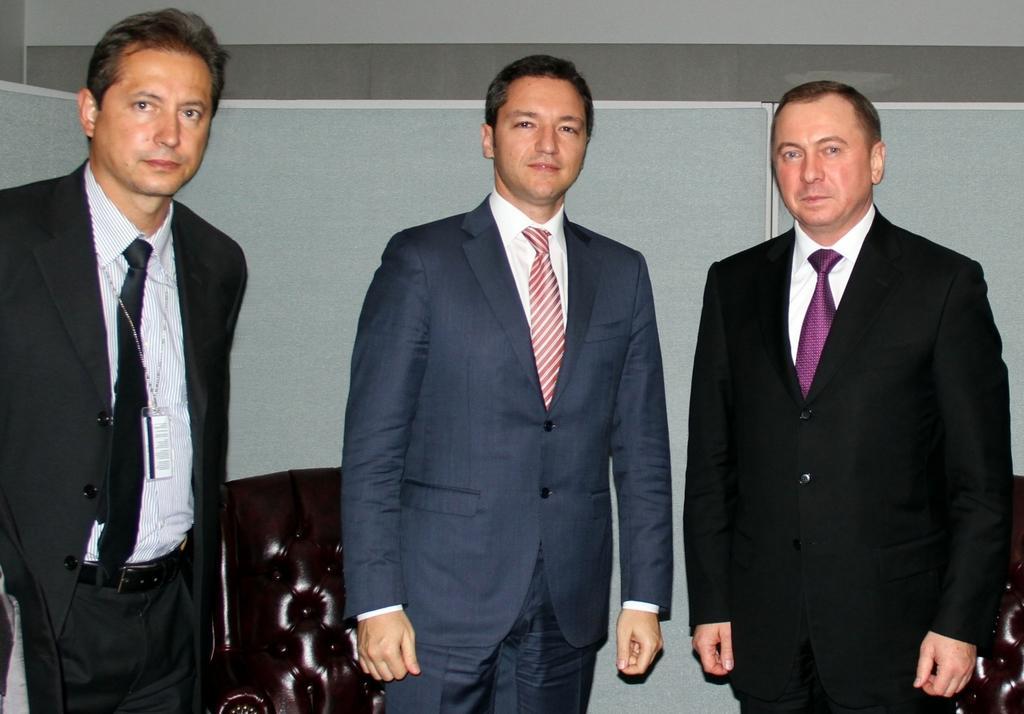Describe this image in one or two sentences. There are three persons standing and they are wearing ties. 